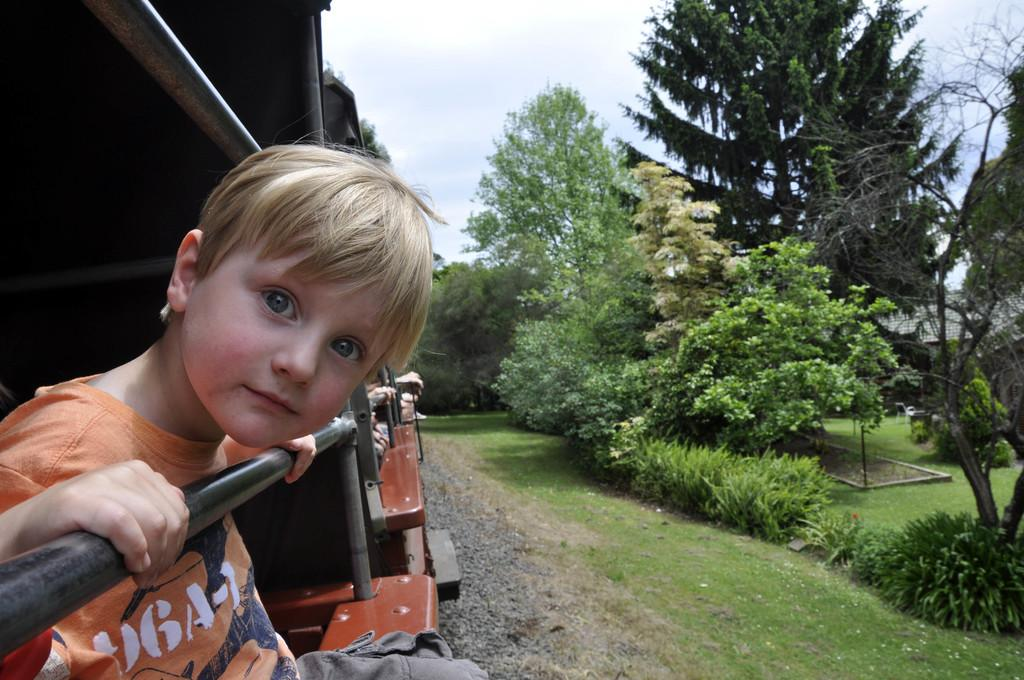What is the main subject in the foreground of the image? There is a train in the foreground of the image. What is the boy in the foreground doing? There is a boy looking through a window in the foreground. What can be seen in the background of the image? There are trees, grass, and the sky visible in the background of the image. How many pizzas is the manager holding in the image? There are no pizzas or managers present in the image. 